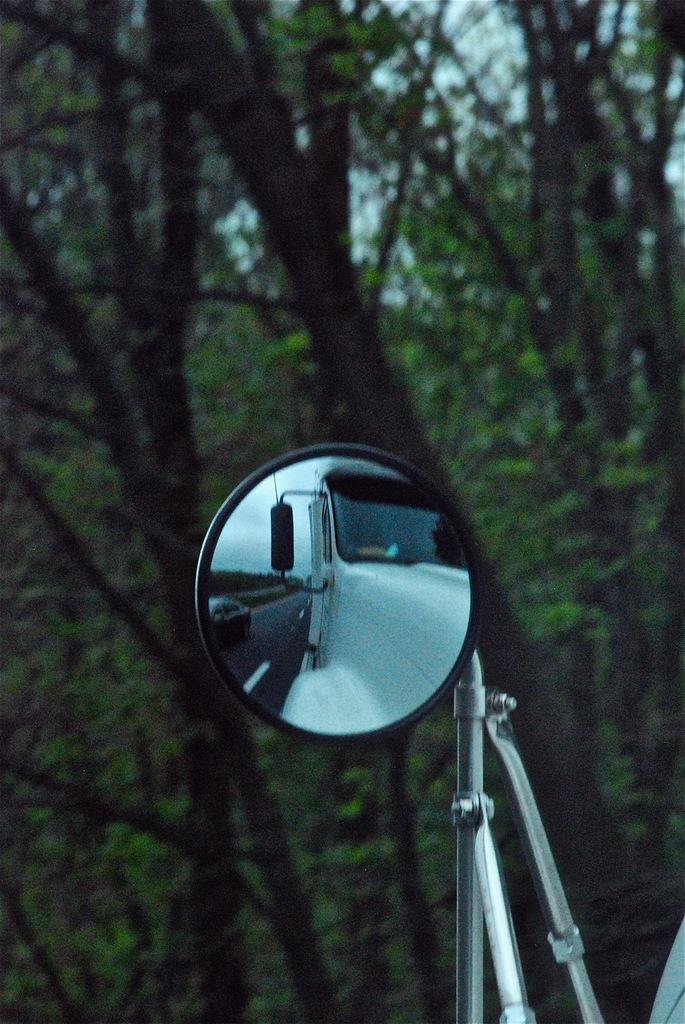What is the main subject of the image? The main subject of the image is a vehicle's side mirror. What can be seen in the side mirror? The side mirror reflects vehicles on the road. What type of natural scenery is visible in the background of the image? There are trees in the background of the image. What else can be seen in the background of the image? The sky is visible in the background of the image. What type of canvas is being used by the person in the image? There is no person or canvas present in the image; it features a vehicle's side mirror reflecting vehicles on the road with trees and the sky in the background. 